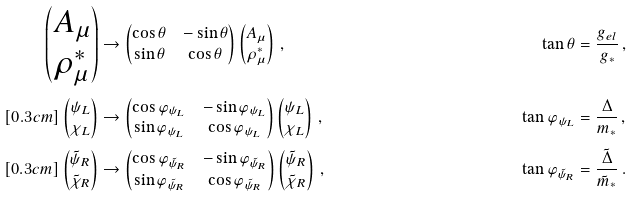<formula> <loc_0><loc_0><loc_500><loc_500>\begin{pmatrix} A _ { \mu } \\ \rho ^ { * } _ { \mu } \end{pmatrix} & \rightarrow \begin{pmatrix} \cos \theta & - \sin \theta \\ \sin \theta & \cos \theta \end{pmatrix} \begin{pmatrix} A _ { \mu } \\ \rho ^ { * } _ { \mu } \end{pmatrix} \, , \quad & \tan \theta & = \frac { g _ { e l } } { g _ { * } } \, , \\ [ 0 . 3 c m ] \begin{pmatrix} \psi _ { L } \\ \chi _ { L } \end{pmatrix} & \rightarrow \begin{pmatrix} \cos \varphi _ { \psi _ { L } } & - \sin \varphi _ { \psi _ { L } } \\ \sin \varphi _ { \psi _ { L } } & \cos \varphi _ { \psi _ { L } } \end{pmatrix} \begin{pmatrix} \psi _ { L } \\ \chi _ { L } \end{pmatrix} \, , \quad & \tan \varphi _ { \psi _ { L } } & = \frac { \Delta } { m _ { * } } \, , \\ [ 0 . 3 c m ] \begin{pmatrix} \tilde { \psi } _ { R } \\ \tilde { \chi } _ { R } \end{pmatrix} & \rightarrow \begin{pmatrix} \cos \varphi _ { \tilde { \psi } _ { R } } & - \sin \varphi _ { \tilde { \psi } _ { R } } \\ \sin \varphi _ { \tilde { \psi } _ { R } } & \cos \varphi _ { \tilde { \psi } _ { R } } \end{pmatrix} \begin{pmatrix} \tilde { \psi } _ { R } \\ \tilde { \chi } _ { R } \end{pmatrix} \, , \quad & \tan \varphi _ { \tilde { \psi } _ { R } } & = \frac { \tilde { \Delta } } { \tilde { m } _ { * } } \, .</formula> 